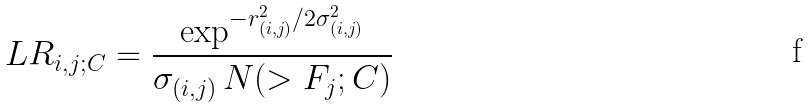<formula> <loc_0><loc_0><loc_500><loc_500>L R _ { i , j ; C } = \frac { \exp ^ { - r _ { ( i , j ) } ^ { 2 } / 2 \sigma ^ { 2 } _ { ( i , j ) } } } { \sigma _ { ( i , j ) } \, N ( > F _ { j } ; C ) }</formula> 